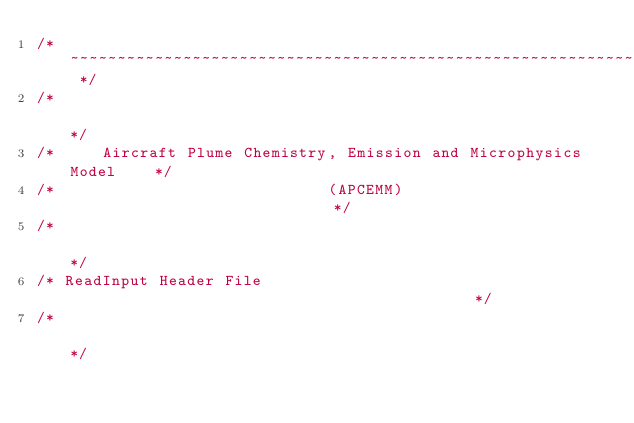<code> <loc_0><loc_0><loc_500><loc_500><_C++_>/* ~~~~~~~~~~~~~~~~~~~~~~~~~~~~~~~~~~~~~~~~~~~~~~~~~~~~~~~~~~~~~~~~ */
/*                                                                  */
/*     Aircraft Plume Chemistry, Emission and Microphysics Model    */
/*                             (APCEMM)                             */
/*                                                                  */
/* ReadInput Header File                                            */
/*                                                                  */</code> 